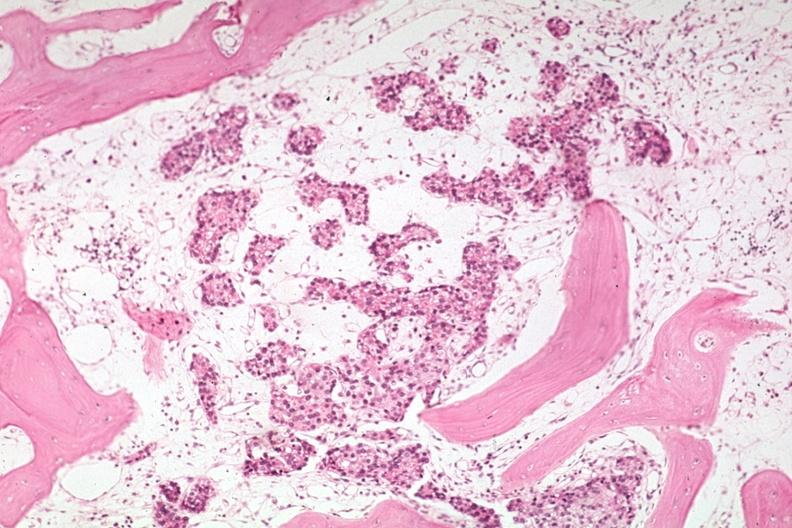s joints present?
Answer the question using a single word or phrase. Yes 